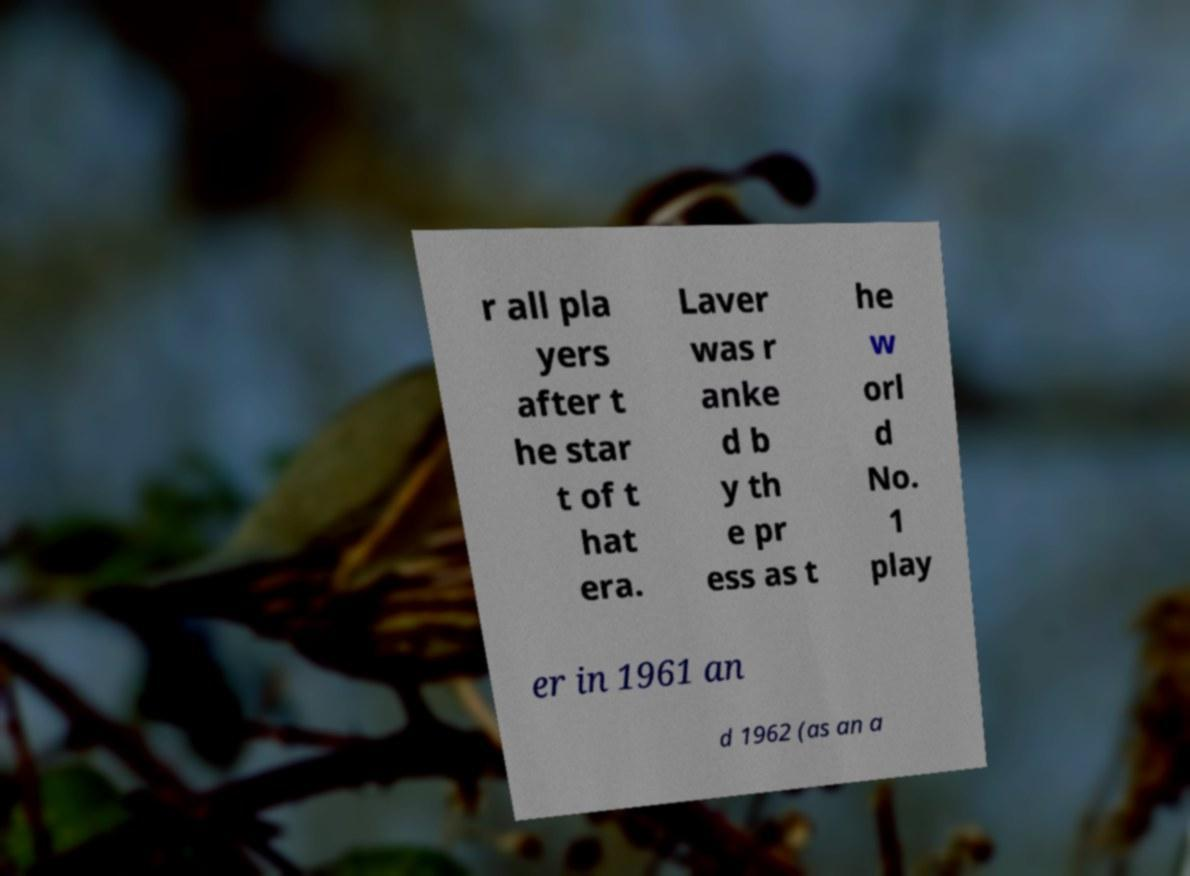Could you extract and type out the text from this image? r all pla yers after t he star t of t hat era. Laver was r anke d b y th e pr ess as t he w orl d No. 1 play er in 1961 an d 1962 (as an a 